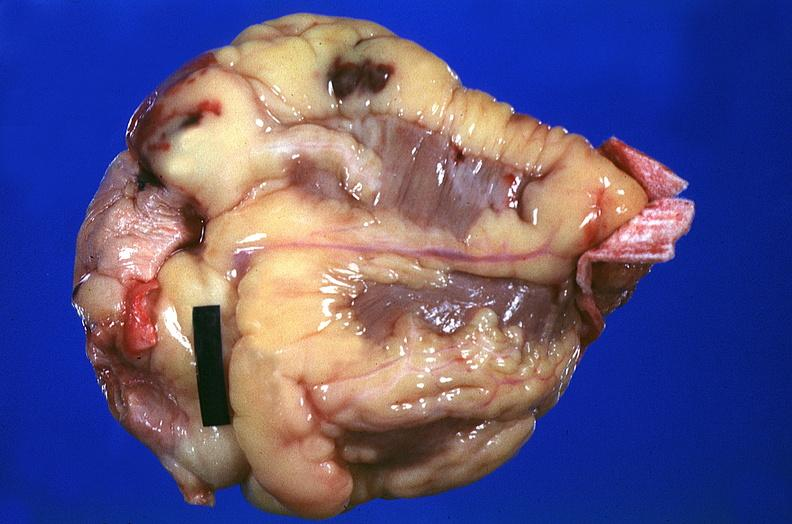where is this?
Answer the question using a single word or phrase. Heart 